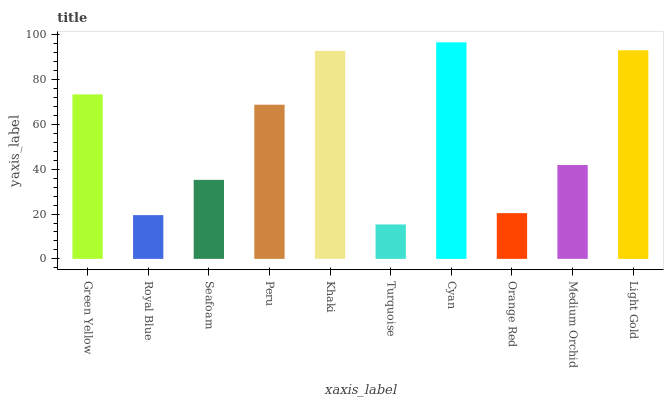Is Turquoise the minimum?
Answer yes or no. Yes. Is Cyan the maximum?
Answer yes or no. Yes. Is Royal Blue the minimum?
Answer yes or no. No. Is Royal Blue the maximum?
Answer yes or no. No. Is Green Yellow greater than Royal Blue?
Answer yes or no. Yes. Is Royal Blue less than Green Yellow?
Answer yes or no. Yes. Is Royal Blue greater than Green Yellow?
Answer yes or no. No. Is Green Yellow less than Royal Blue?
Answer yes or no. No. Is Peru the high median?
Answer yes or no. Yes. Is Medium Orchid the low median?
Answer yes or no. Yes. Is Khaki the high median?
Answer yes or no. No. Is Orange Red the low median?
Answer yes or no. No. 